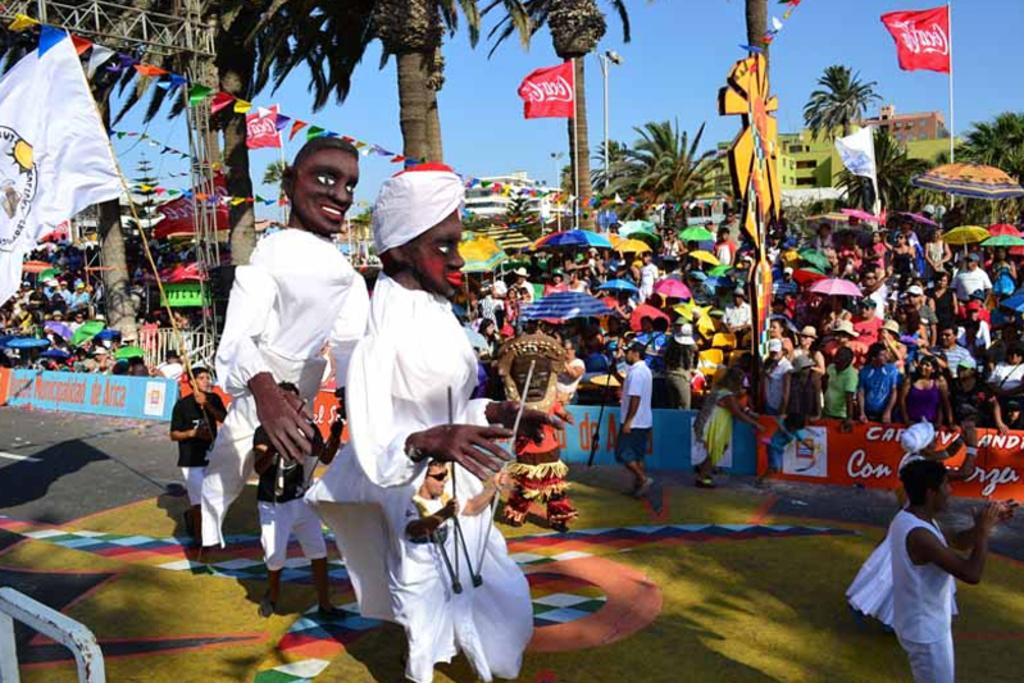What company advertised during this parade?
Provide a short and direct response. Coca cola. What 3 letter word is written in white on the red banner?
Keep it short and to the point. Con. 